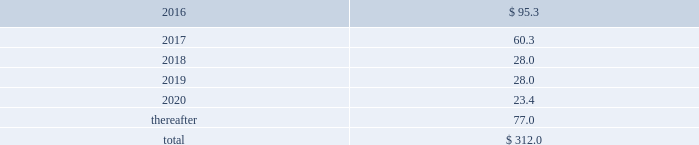Interest expense related to capital lease obligations was $ 1.6 million during the year ended december 31 , 2015 , and $ 1.6 million during both the years ended december 31 , 2014 and 2013 .
Purchase commitments in the table below , we set forth our enforceable and legally binding purchase obligations as of december 31 , 2015 .
Some of the amounts are based on management 2019s estimates and assumptions about these obligations , including their duration , the possibility of renewal , anticipated actions by third parties , and other factors .
Because these estimates and assumptions are necessarily subjective , our actual payments may vary from those reflected in the table .
Purchase orders made in the ordinary course of business are excluded below .
Any amounts for which we are liable under purchase orders are reflected on the consolidated balance sheets as accounts payable and accrued liabilities .
These obligations relate to various purchase agreements for items such as minimum amounts of fiber and energy purchases over periods ranging from one year to 20 years .
Total purchase commitments were as follows ( dollars in millions ) : .
The company purchased a total of $ 299.6 million , $ 265.9 million , and $ 61.7 million during the years ended december 31 , 2015 , 2014 , and 2013 , respectively , under these purchase agreements .
The increase in purchases the increase in purchases under these agreements in 2014 , compared with 2013 , relates to the acquisition of boise in fourth quarter 2013 .
Environmental liabilities the potential costs for various environmental matters are uncertain due to such factors as the unknown magnitude of possible cleanup costs , the complexity and evolving nature of governmental laws and regulations and their interpretations , and the timing , varying costs and effectiveness of alternative cleanup technologies .
From 2006 through 2015 , there were no significant environmental remediation costs at pca 2019s mills and corrugated plants .
At december 31 , 2015 , the company had $ 24.3 million of environmental-related reserves recorded on its consolidated balance sheet .
Of the $ 24.3 million , approximately $ 15.8 million related to environmental-related asset retirement obligations discussed in note 12 , asset retirement obligations , and $ 8.5 million related to our estimate of other environmental contingencies .
The company recorded $ 7.9 million in 201caccrued liabilities 201d and $ 16.4 million in 201cother long-term liabilities 201d on the consolidated balance sheet .
Liabilities recorded for environmental contingencies are estimates of the probable costs based upon available information and assumptions .
Because of these uncertainties , pca 2019s estimates may change .
The company believes that it is not reasonably possible that future environmental expenditures for remediation costs and asset retirement obligations above the $ 24.3 million accrued as of december 31 , 2015 , will have a material impact on its financial condition , results of operations , or cash flows .
Guarantees and indemnifications we provide guarantees , indemnifications , and other assurances to third parties in the normal course of our business .
These include tort indemnifications , environmental assurances , and representations and warranties in commercial agreements .
At december 31 , 2015 , we are not aware of any material liabilities arising from any guarantee , indemnification , or financial assurance we have provided .
If we determined such a liability was probable and subject to reasonable determination , we would accrue for it at that time. .
What percentage of total purchase commitments are due in 2016? 
Computations: (95.3 / 312.0)
Answer: 0.30545. Interest expense related to capital lease obligations was $ 1.6 million during the year ended december 31 , 2015 , and $ 1.6 million during both the years ended december 31 , 2014 and 2013 .
Purchase commitments in the table below , we set forth our enforceable and legally binding purchase obligations as of december 31 , 2015 .
Some of the amounts are based on management 2019s estimates and assumptions about these obligations , including their duration , the possibility of renewal , anticipated actions by third parties , and other factors .
Because these estimates and assumptions are necessarily subjective , our actual payments may vary from those reflected in the table .
Purchase orders made in the ordinary course of business are excluded below .
Any amounts for which we are liable under purchase orders are reflected on the consolidated balance sheets as accounts payable and accrued liabilities .
These obligations relate to various purchase agreements for items such as minimum amounts of fiber and energy purchases over periods ranging from one year to 20 years .
Total purchase commitments were as follows ( dollars in millions ) : .
The company purchased a total of $ 299.6 million , $ 265.9 million , and $ 61.7 million during the years ended december 31 , 2015 , 2014 , and 2013 , respectively , under these purchase agreements .
The increase in purchases the increase in purchases under these agreements in 2014 , compared with 2013 , relates to the acquisition of boise in fourth quarter 2013 .
Environmental liabilities the potential costs for various environmental matters are uncertain due to such factors as the unknown magnitude of possible cleanup costs , the complexity and evolving nature of governmental laws and regulations and their interpretations , and the timing , varying costs and effectiveness of alternative cleanup technologies .
From 2006 through 2015 , there were no significant environmental remediation costs at pca 2019s mills and corrugated plants .
At december 31 , 2015 , the company had $ 24.3 million of environmental-related reserves recorded on its consolidated balance sheet .
Of the $ 24.3 million , approximately $ 15.8 million related to environmental-related asset retirement obligations discussed in note 12 , asset retirement obligations , and $ 8.5 million related to our estimate of other environmental contingencies .
The company recorded $ 7.9 million in 201caccrued liabilities 201d and $ 16.4 million in 201cother long-term liabilities 201d on the consolidated balance sheet .
Liabilities recorded for environmental contingencies are estimates of the probable costs based upon available information and assumptions .
Because of these uncertainties , pca 2019s estimates may change .
The company believes that it is not reasonably possible that future environmental expenditures for remediation costs and asset retirement obligations above the $ 24.3 million accrued as of december 31 , 2015 , will have a material impact on its financial condition , results of operations , or cash flows .
Guarantees and indemnifications we provide guarantees , indemnifications , and other assurances to third parties in the normal course of our business .
These include tort indemnifications , environmental assurances , and representations and warranties in commercial agreements .
At december 31 , 2015 , we are not aware of any material liabilities arising from any guarantee , indemnification , or financial assurance we have provided .
If we determined such a liability was probable and subject to reasonable determination , we would accrue for it at that time. .
At december 31 , 2015 , what percent of the environmental-related reserves related to environmental-related asset retirement obligations ? 
Computations: (15.8 / 24.3)
Answer: 0.65021. 